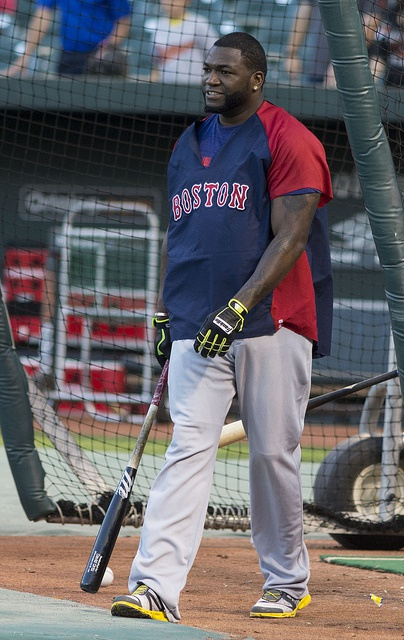Describe the objects in this image and their specific colors. I can see people in brown, navy, darkgray, lightgray, and black tones, people in brown, gray, navy, darkblue, and black tones, people in brown, darkgray, and gray tones, baseball bat in brown, black, gray, darkgray, and lightgray tones, and baseball bat in brown, black, ivory, gray, and darkgray tones in this image. 